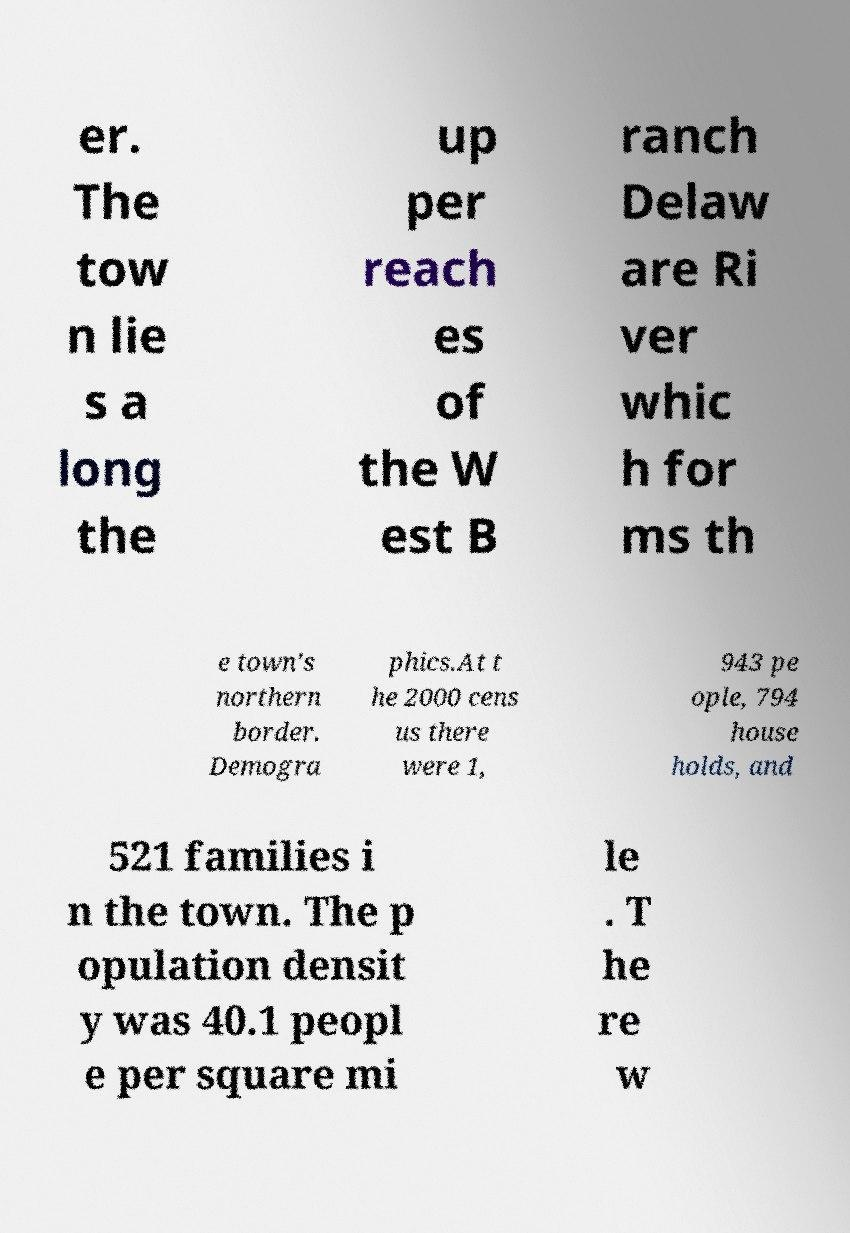Please identify and transcribe the text found in this image. er. The tow n lie s a long the up per reach es of the W est B ranch Delaw are Ri ver whic h for ms th e town's northern border. Demogra phics.At t he 2000 cens us there were 1, 943 pe ople, 794 house holds, and 521 families i n the town. The p opulation densit y was 40.1 peopl e per square mi le . T he re w 